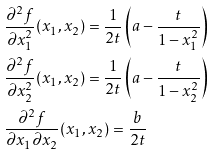Convert formula to latex. <formula><loc_0><loc_0><loc_500><loc_500>& \frac { \partial ^ { 2 } f } { \partial x _ { 1 } ^ { 2 } } ( x _ { 1 } , x _ { 2 } ) = \frac { 1 } { 2 t } \left ( a - \frac { t } { 1 - x _ { 1 } ^ { 2 } } \right ) \\ & \frac { \partial ^ { 2 } f } { \partial x _ { 2 } ^ { 2 } } ( x _ { 1 } , x _ { 2 } ) = \frac { 1 } { 2 t } \left ( a - \frac { t } { 1 - x _ { 2 } ^ { 2 } } \right ) \\ & \frac { \partial ^ { 2 } f } { \partial x _ { 1 } \partial x _ { 2 } } ( x _ { 1 } , x _ { 2 } ) = \frac { b } { 2 t }</formula> 